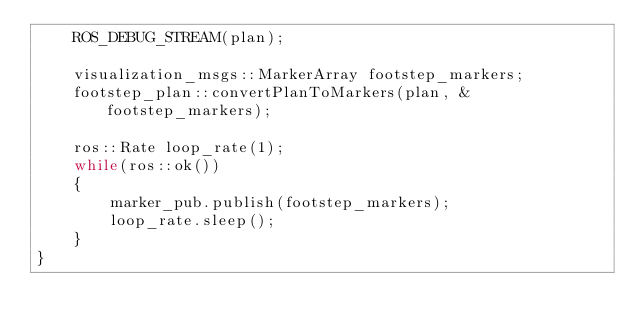<code> <loc_0><loc_0><loc_500><loc_500><_C++_>	ROS_DEBUG_STREAM(plan);

	visualization_msgs::MarkerArray footstep_markers;
	footstep_plan::convertPlanToMarkers(plan, &footstep_markers);
	
	ros::Rate loop_rate(1);
	while(ros::ok())
	{
		marker_pub.publish(footstep_markers);
		loop_rate.sleep();
	}
}
</code> 